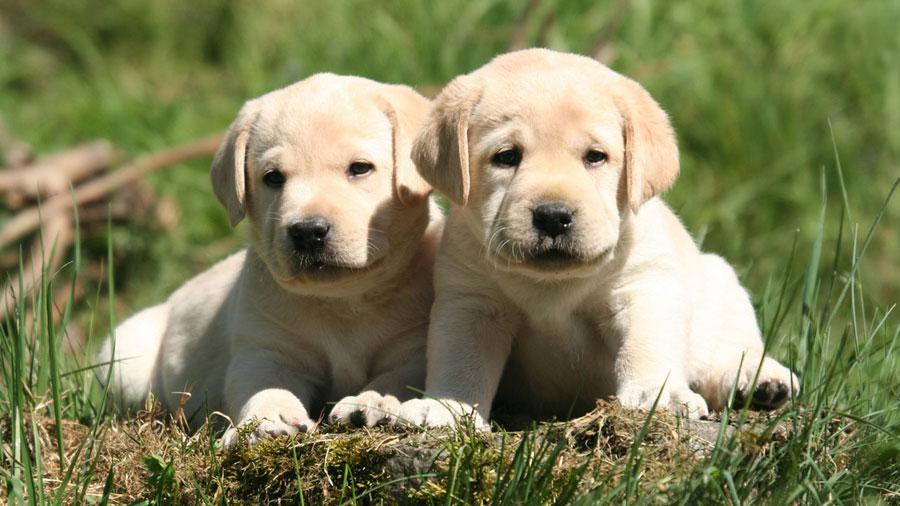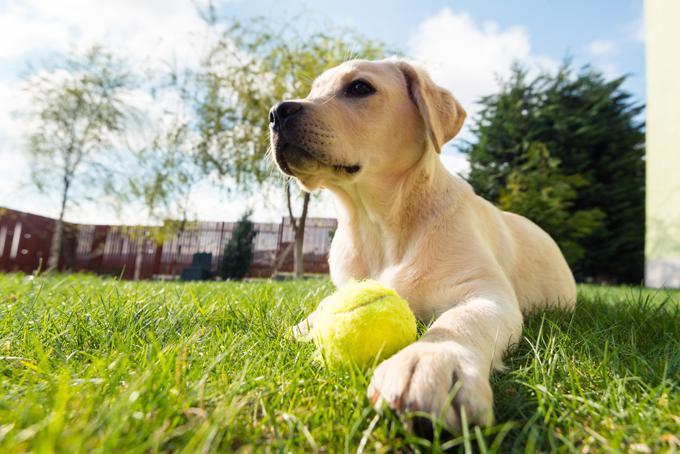The first image is the image on the left, the second image is the image on the right. Examine the images to the left and right. Is the description "There are at least four dogs." accurate? Answer yes or no. No. 